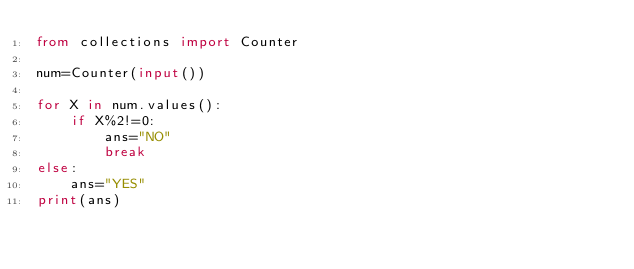<code> <loc_0><loc_0><loc_500><loc_500><_Python_>from collections import Counter

num=Counter(input())

for X in num.values():
    if X%2!=0:
        ans="NO"
        break
else:
    ans="YES"  
print(ans)</code> 